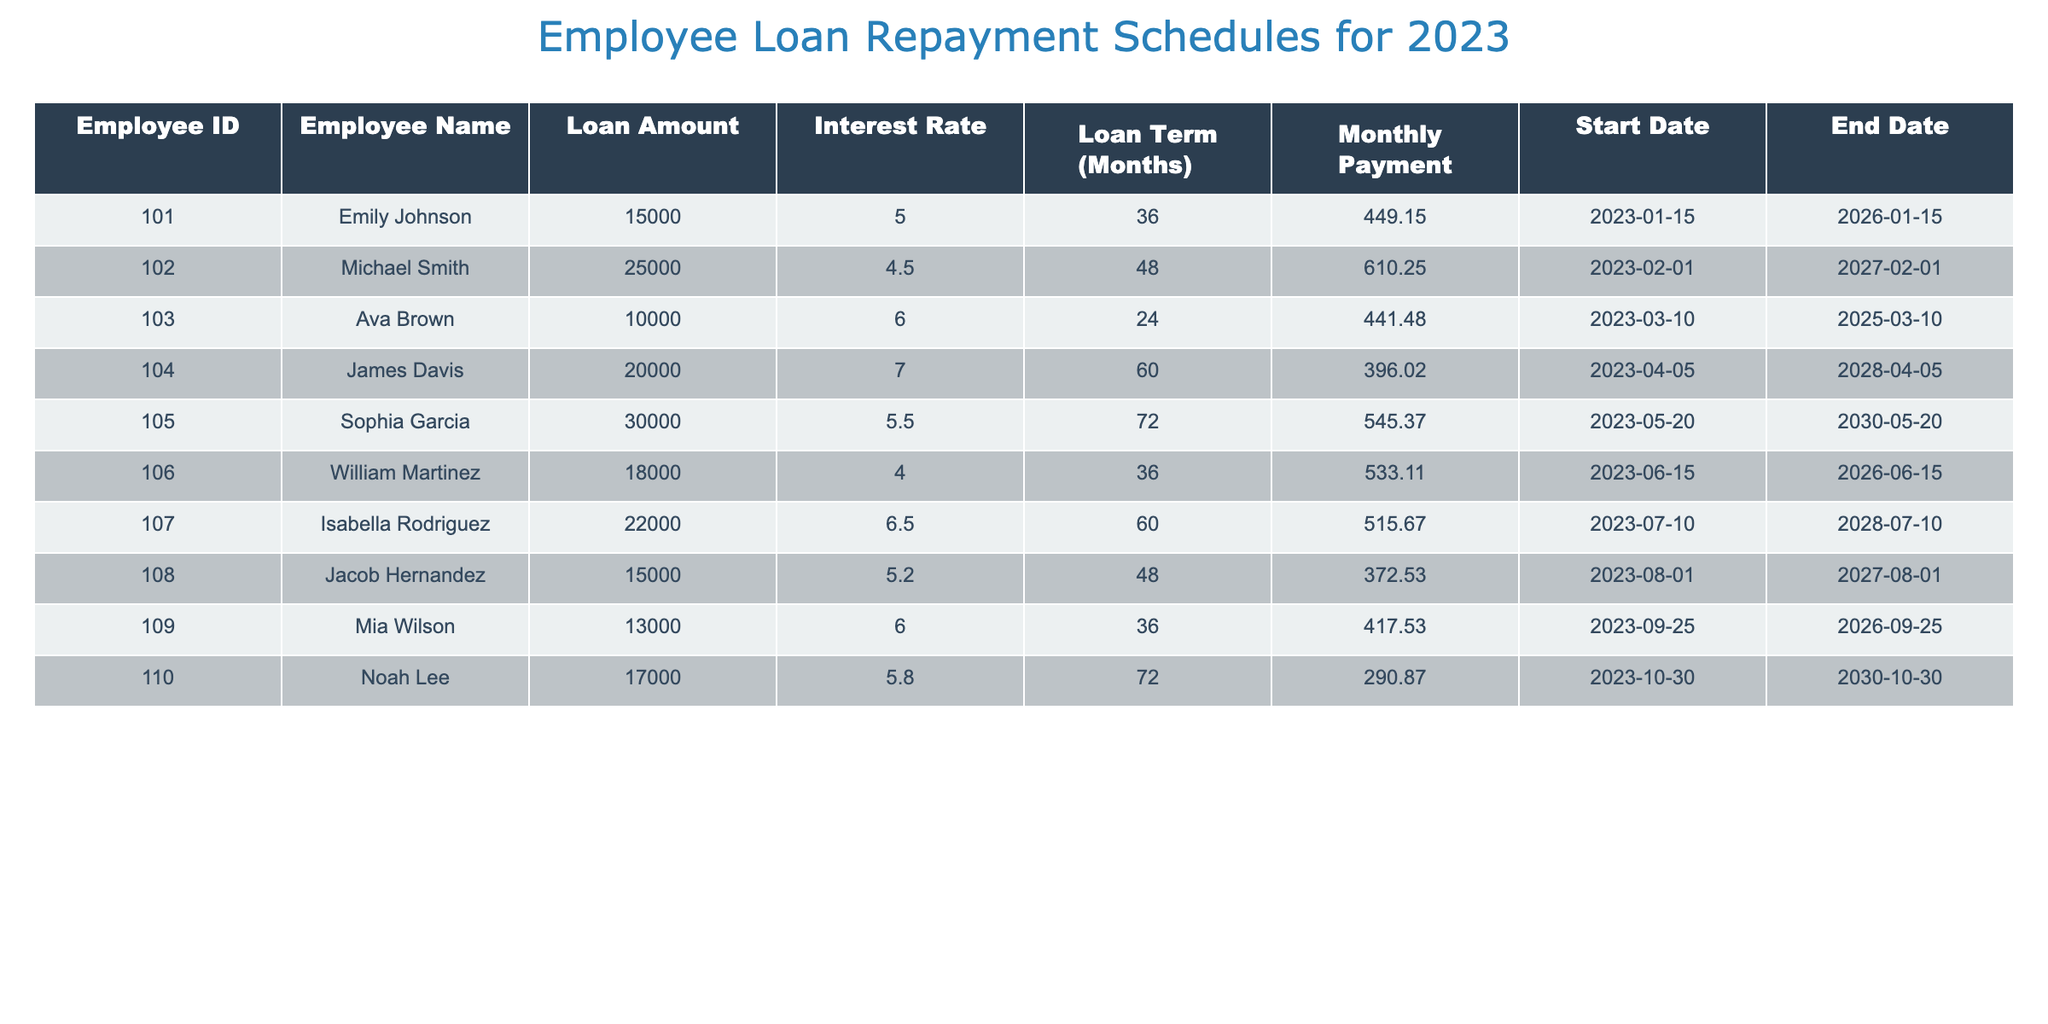What is the total loan amount for all employees? To find the total loan amount, we sum the individual loan amounts from the table: 15000 + 25000 + 10000 + 20000 + 30000 + 18000 + 22000 + 15000 + 13000 + 17000 = 180000.
Answer: 180000 Which employee has the highest monthly payment? By inspecting the monthly payment column, we identify the monthly payments: 449.15, 610.25, 441.48, 396.02, 545.37, 533.11, 515.67, 372.53, 417.53, 290.87. The highest value is 610.25, associated with Michael Smith.
Answer: Michael Smith Is the loan term for Sophia Garcia longer than 60 months? Sophia Garcia's loan term is 72 months. Since 72 is greater than 60, the answer is yes.
Answer: Yes What is the average interest rate for the loans? The interest rates are 5.0, 4.5, 6.0, 7.0, 5.5, 4.0, 6.5, 5.2, 6.0, 5.8. We calculate the average by summing these rates (5.0 + 4.5 + 6.0 + 7.0 + 5.5 + 4.0 + 6.5 + 5.2 + 6.0 + 5.8 = 56.5) and dividing by the number of loans (10): 56.5 / 10 = 5.65.
Answer: 5.65 Which employee has a loan that ends the earliest? To determine this, we check the end dates: 2026-01-15, 2027-02-01, 2025-03-10, 2028-04-05, 2030-05-20, 2026-06-15, 2028-07-10, 2027-08-01, 2026-09-25, 2030-10-30. The earliest date is 2025-03-10, linked to Ava Brown.
Answer: Ava Brown 